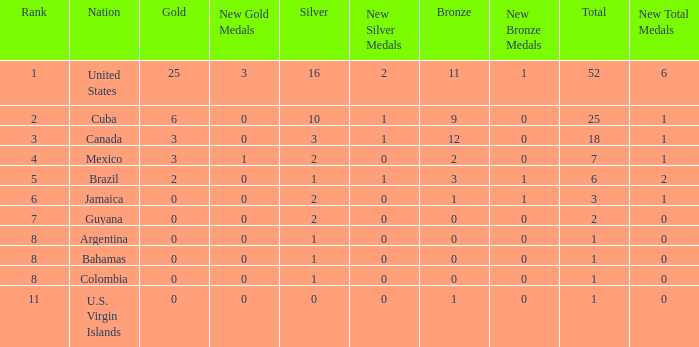What is the fewest number of silver medals a nation who ranked below 8 received? 0.0. 